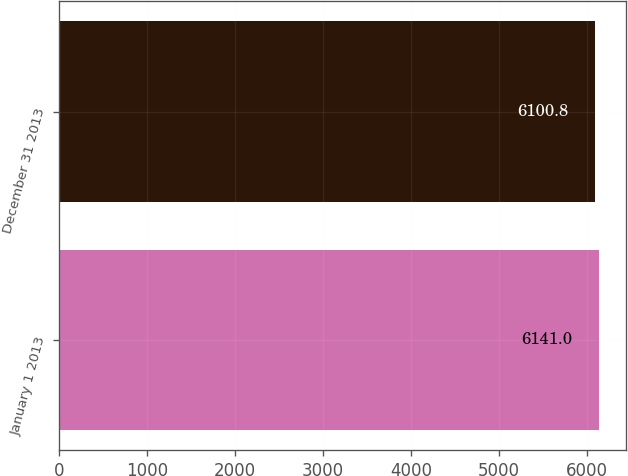Convert chart to OTSL. <chart><loc_0><loc_0><loc_500><loc_500><bar_chart><fcel>January 1 2013<fcel>December 31 2013<nl><fcel>6141<fcel>6100.8<nl></chart> 